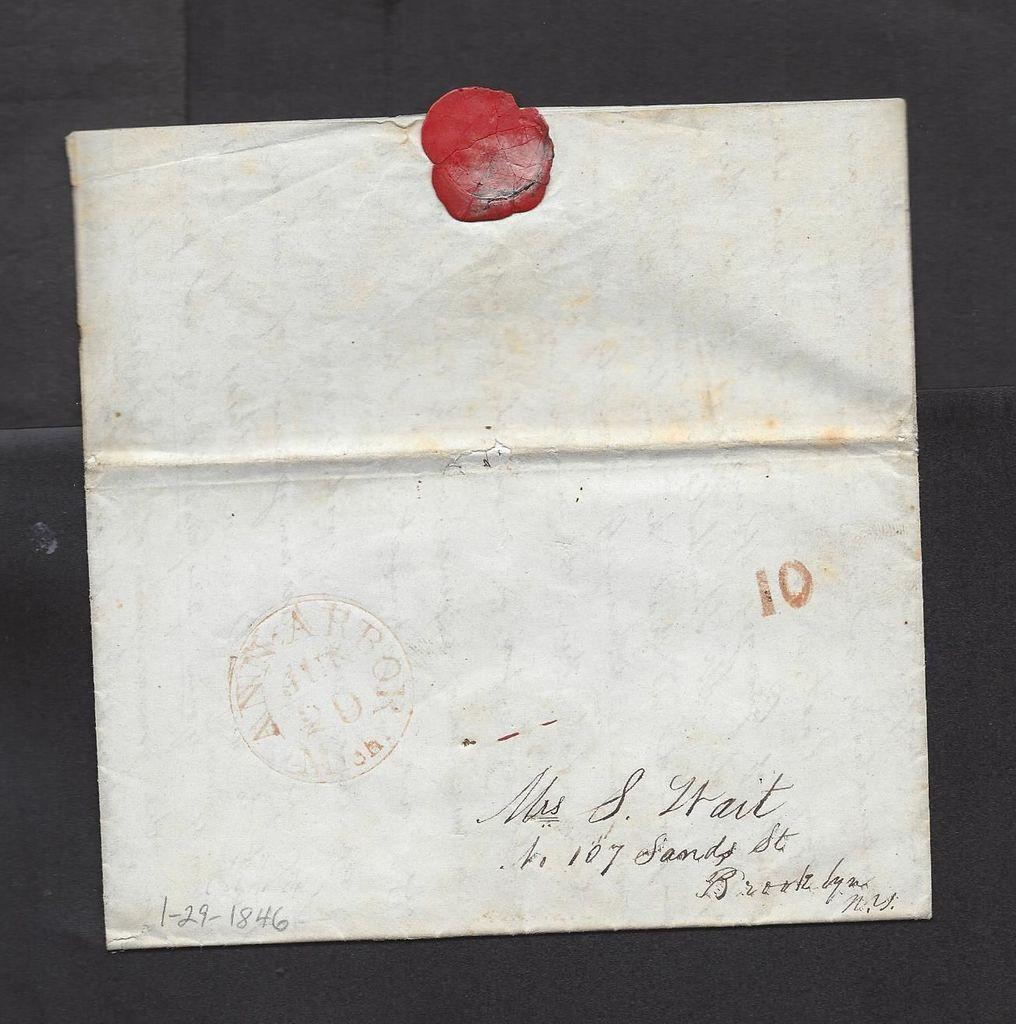<image>
Provide a brief description of the given image. An old envelope with a red seal addressed to Mrs S. Wait. 